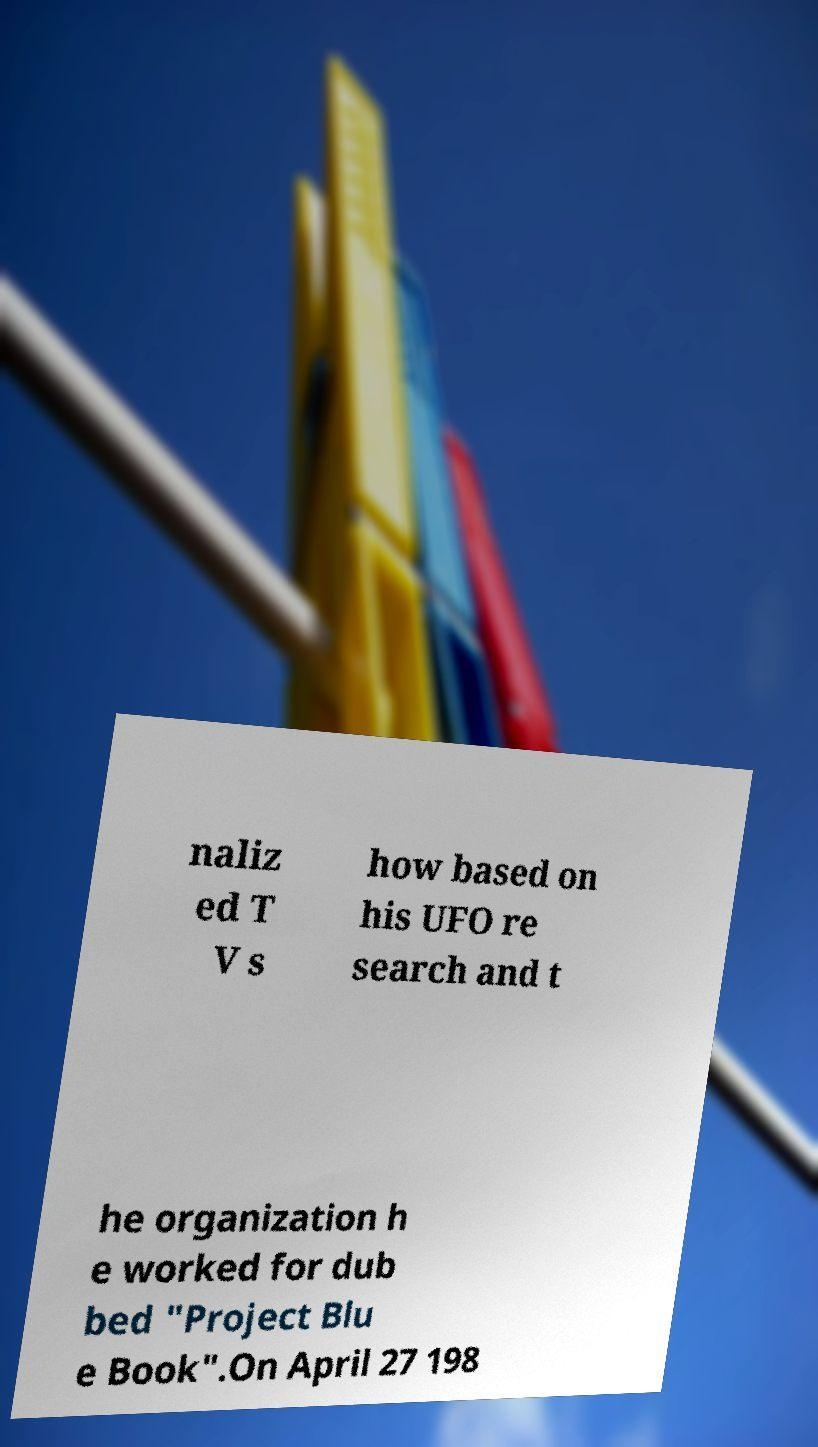Can you accurately transcribe the text from the provided image for me? naliz ed T V s how based on his UFO re search and t he organization h e worked for dub bed "Project Blu e Book".On April 27 198 